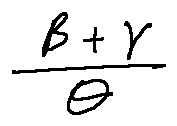Convert formula to latex. <formula><loc_0><loc_0><loc_500><loc_500>\frac { \beta + \gamma } { \theta }</formula> 